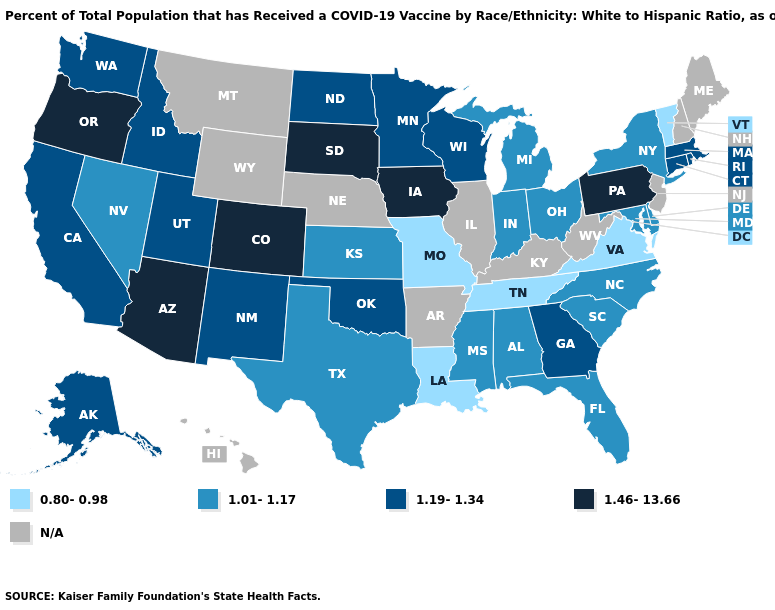What is the value of Maryland?
Give a very brief answer. 1.01-1.17. What is the value of Kansas?
Keep it brief. 1.01-1.17. What is the highest value in the West ?
Write a very short answer. 1.46-13.66. Does Missouri have the lowest value in the MidWest?
Concise answer only. Yes. Name the states that have a value in the range 1.19-1.34?
Concise answer only. Alaska, California, Connecticut, Georgia, Idaho, Massachusetts, Minnesota, New Mexico, North Dakota, Oklahoma, Rhode Island, Utah, Washington, Wisconsin. Which states hav the highest value in the South?
Quick response, please. Georgia, Oklahoma. Does Nevada have the lowest value in the West?
Be succinct. Yes. Name the states that have a value in the range N/A?
Quick response, please. Arkansas, Hawaii, Illinois, Kentucky, Maine, Montana, Nebraska, New Hampshire, New Jersey, West Virginia, Wyoming. What is the value of Washington?
Answer briefly. 1.19-1.34. What is the lowest value in the MidWest?
Answer briefly. 0.80-0.98. Among the states that border Nevada , which have the lowest value?
Answer briefly. California, Idaho, Utah. What is the value of North Carolina?
Concise answer only. 1.01-1.17. 